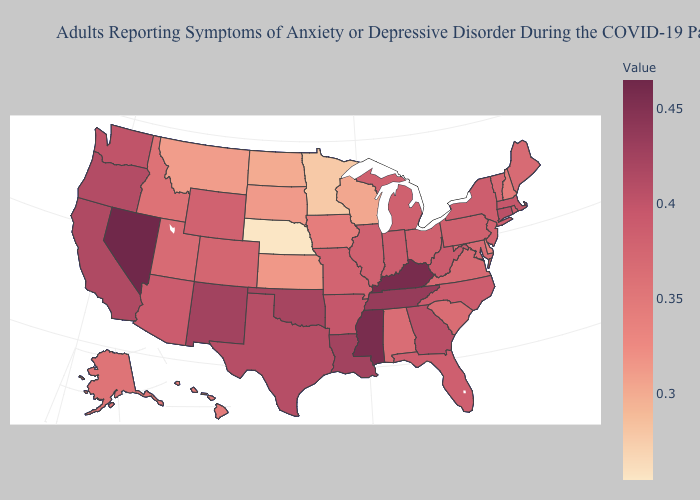Does the map have missing data?
Write a very short answer. No. Does Nebraska have the lowest value in the USA?
Quick response, please. Yes. Which states hav the highest value in the South?
Write a very short answer. Kentucky. Does the map have missing data?
Give a very brief answer. No. Among the states that border New Mexico , which have the lowest value?
Give a very brief answer. Utah. Does Arkansas have the lowest value in the USA?
Concise answer only. No. Does New York have a lower value than Mississippi?
Short answer required. Yes. 